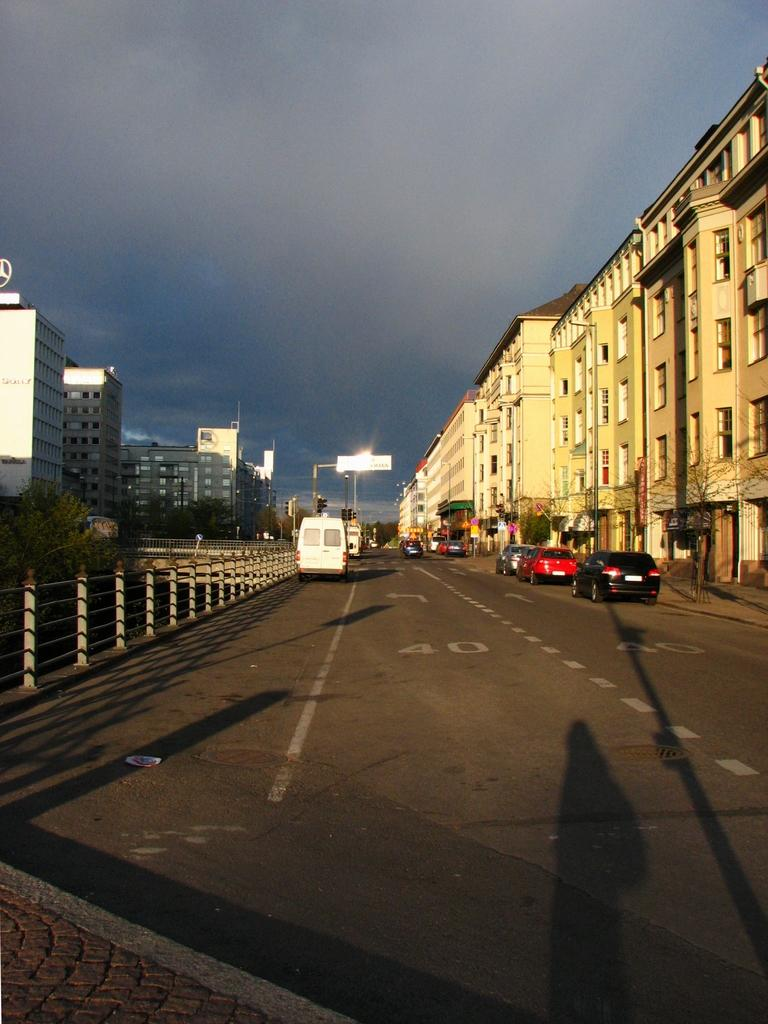What can be seen on the road in the image? There are vehicles on the road in the image. What type of barrier is present in the image? There is a fence in the image. What can be seen in the distance in the image? There are buildings and trees in the background of the image. What is visible above the buildings and trees in the image? The sky is visible in the background of the image. What type of pencil is being used to draw the acoustics of the distribution in the image? There is no pencil, acoustics, or distribution present in the image. 